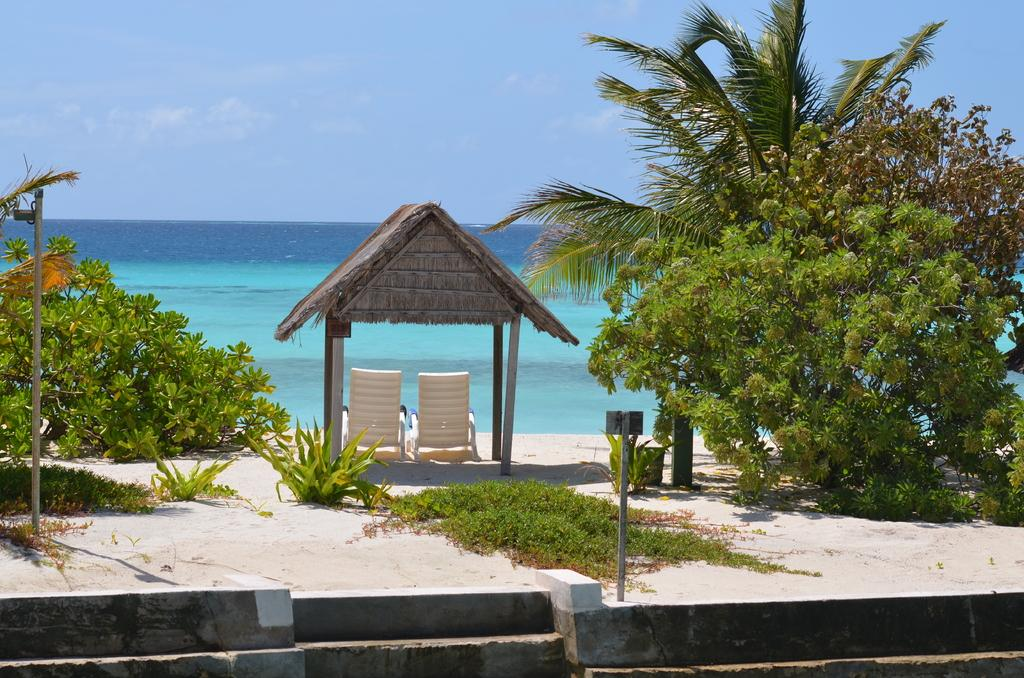What type of furniture is located under the shed in the image? There are chairs under the shed in the image. What is one of the architectural features visible in the image? There is a wall visible in the image. What type of natural vegetation is present in the image? Trees and plants are visible in the image. What type of support structures are present in the image? Poles are present in the image. What type of liquid is visible in the image? There is water visible in the image. What part of the natural environment is visible in the image? The sky is visible in the image. What type of breakfast is being prepared in the image? There is no indication of breakfast preparation in the image. How many drops can be seen falling from the sky in the image? There are no drops visible in the image; it is not raining. 